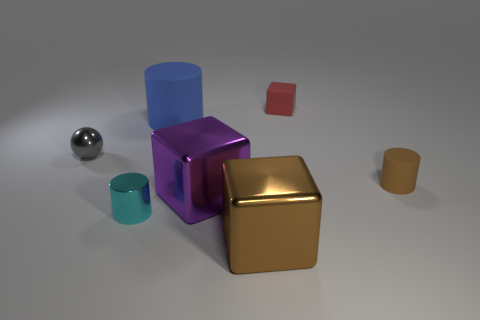Add 1 tiny brown matte spheres. How many objects exist? 8 Subtract all tiny metal cylinders. How many cylinders are left? 2 Subtract all spheres. How many objects are left? 6 Subtract 1 blocks. How many blocks are left? 2 Subtract all purple cubes. Subtract all yellow cylinders. How many cubes are left? 2 Subtract all cyan blocks. How many cyan spheres are left? 0 Subtract all cyan cylinders. Subtract all cyan cylinders. How many objects are left? 5 Add 7 large purple metal cubes. How many large purple metal cubes are left? 8 Add 6 green matte objects. How many green matte objects exist? 6 Subtract 0 purple balls. How many objects are left? 7 